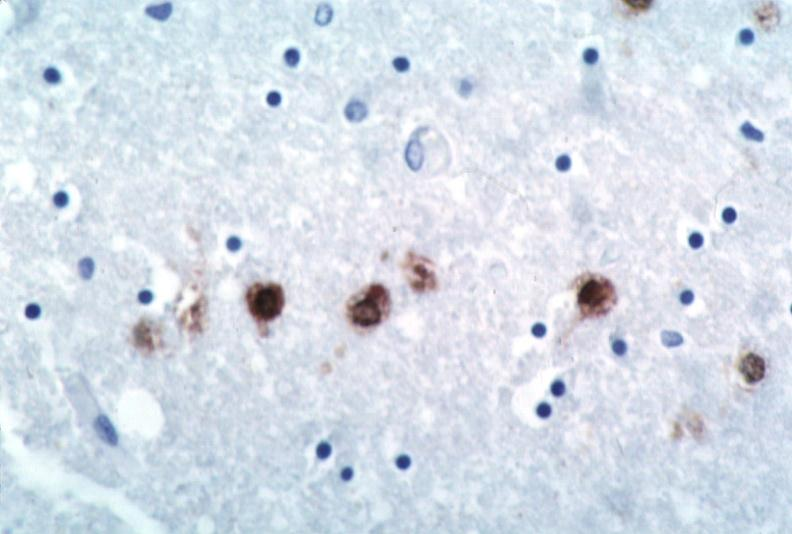does oil acid show brain, herpes encephalitis?
Answer the question using a single word or phrase. No 